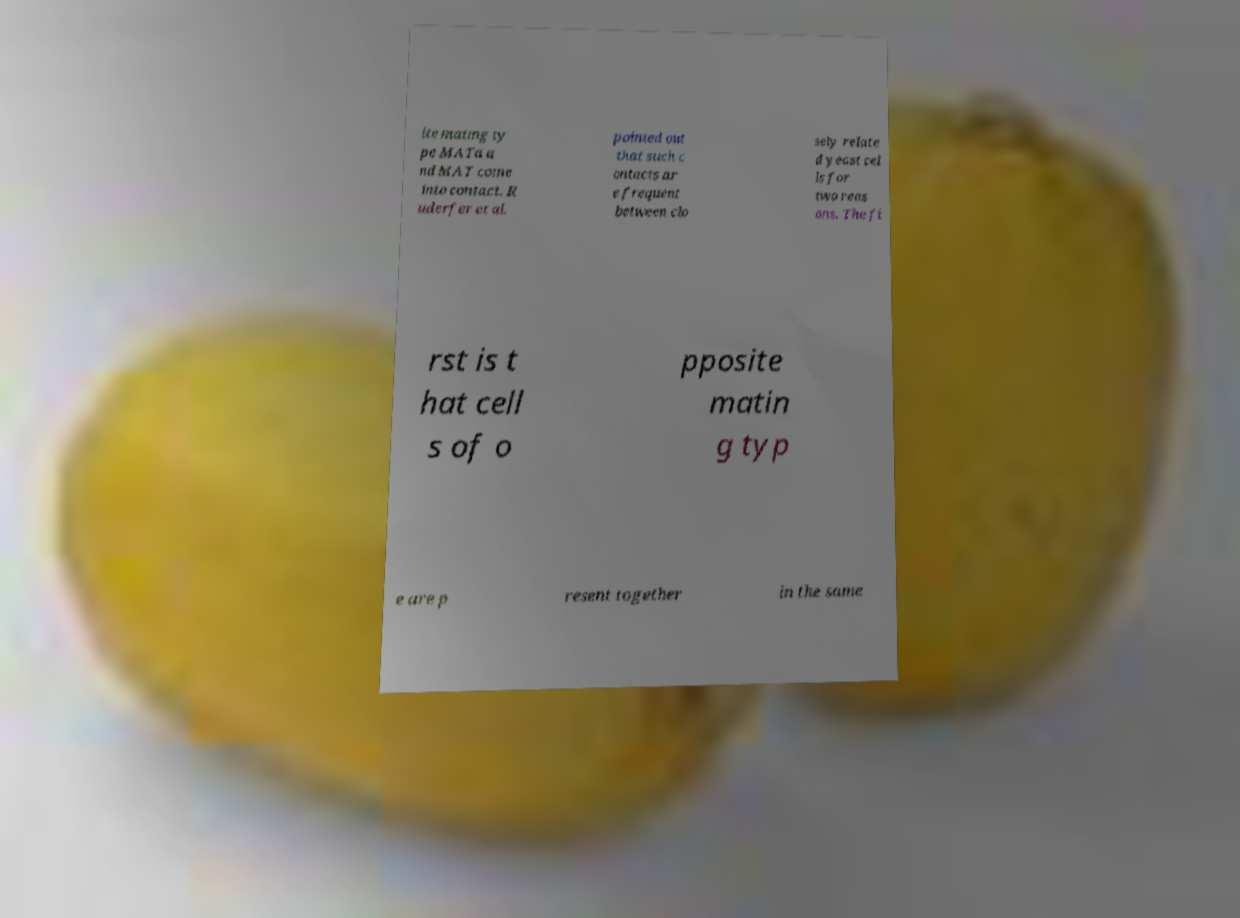What messages or text are displayed in this image? I need them in a readable, typed format. ite mating ty pe MATa a nd MAT come into contact. R uderfer et al. pointed out that such c ontacts ar e frequent between clo sely relate d yeast cel ls for two reas ons. The fi rst is t hat cell s of o pposite matin g typ e are p resent together in the same 